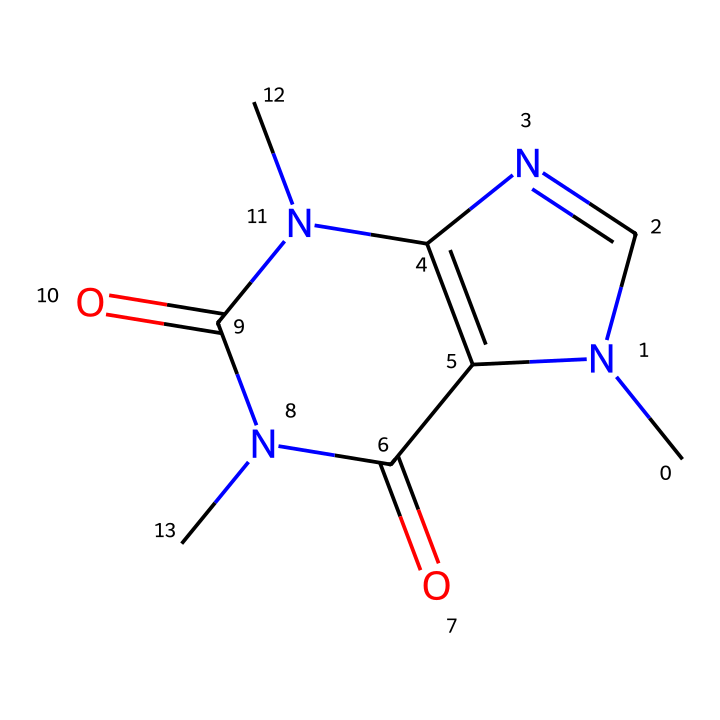What is the molecular formula of caffeine? By analyzing the SMILES representation, we can count the number of atoms present for each element. The structure reveals that there are 8 carbon (C) atoms, 10 hydrogen (H) atoms, 4 nitrogen (N) atoms, and 2 oxygen (O) atoms. Therefore, the molecular formula is C8H10N4O2.
Answer: C8H10N4O2 How many nitrogen atoms are in the structure of caffeine? Reviewing the SMILES representation, we can identify the nitrogen atoms indicated by 'N'. There are four nitrogen atoms present in the structure.
Answer: 4 Is caffeine an aromatic compound? The structure contains a benzene-like ring with alternating double bonds, which characterizes aromatic compounds. Additionally, the presence of resonance allows for delocalized electrons, a defining feature of aromaticity.
Answer: Yes What type of functional groups are present in caffeine? From the structure, we can identify that caffeine contains amine groups (-NH) and carbonyl groups (C=O). The presence of these groups indicates the functional nature of caffeine as it relates to its activity.
Answer: Amine and carbonyl What is the bond type between the carbon and nitrogen atoms in caffeine? Looking closely at the structure, the bonds connecting the carbon atoms to the nitrogen atoms are primarily single bonds, except where the nitrogen is involved in imine formations through double bonds, which are also present. But in combination, we find both types.
Answer: Single and double What types of interactions would caffeine likely participate in due to its structure? Given the presence of polar functional groups such as amine and carbonyl, caffeine can engage in hydrogen bonding and dipole-dipole interactions. These interactions are significant in physiological contexts, such as within biological systems.
Answer: Hydrogen bonding and dipole-dipole interactions How many rings are present in the structure of caffeine? Analyzing the depiction of caffeine in the SMILES notation, we find two distinct ring structures that contribute to its cyclic nature, particularly due to the fused ring system present in the compound.
Answer: 2 